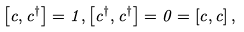<formula> <loc_0><loc_0><loc_500><loc_500>\left [ c , c ^ { \dagger } \right ] = 1 , \left [ c ^ { \dagger } , c ^ { \dagger } \right ] = 0 = \left [ c , c \right ] ,</formula> 